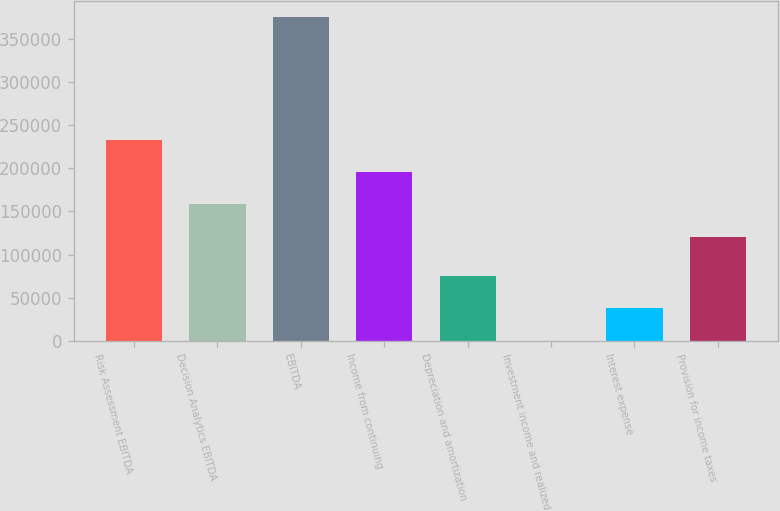Convert chart to OTSL. <chart><loc_0><loc_0><loc_500><loc_500><bar_chart><fcel>Risk Assessment EBITDA<fcel>Decision Analytics EBITDA<fcel>EBITDA<fcel>Income from continuing<fcel>Depreciation and amortization<fcel>Investment income and realized<fcel>Interest expense<fcel>Provision for income taxes<nl><fcel>233197<fcel>158180<fcel>375414<fcel>195688<fcel>75344.4<fcel>327<fcel>37835.7<fcel>120671<nl></chart> 